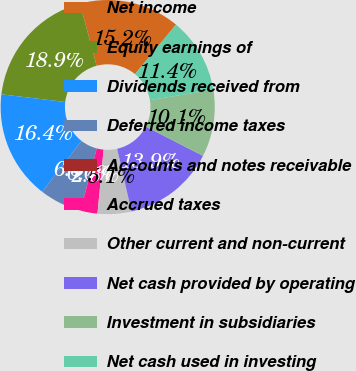Convert chart. <chart><loc_0><loc_0><loc_500><loc_500><pie_chart><fcel>Net income<fcel>Equity earnings of<fcel>Dividends received from<fcel>Deferred income taxes<fcel>Accounts and notes receivable<fcel>Accrued taxes<fcel>Other current and non-current<fcel>Net cash provided by operating<fcel>Investment in subsidiaries<fcel>Net cash used in investing<nl><fcel>15.17%<fcel>18.95%<fcel>16.43%<fcel>6.35%<fcel>0.04%<fcel>2.56%<fcel>5.09%<fcel>13.91%<fcel>10.13%<fcel>11.39%<nl></chart> 